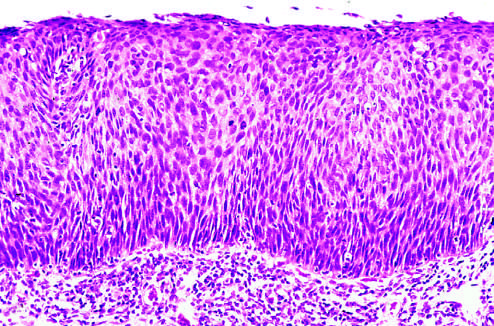s the section of an involved lacrimal gland no tumor in the subepithelial stroma?
Answer the question using a single word or phrase. No 